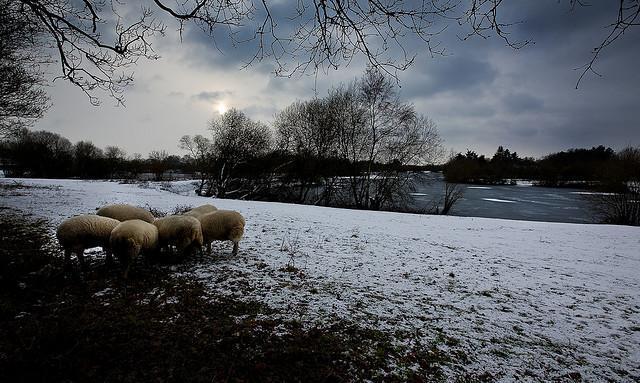These animals are in a formation that is reminiscent of what sport?
Select the accurate response from the four choices given to answer the question.
Options: Ping pong, tennis, archery, football. Football. 